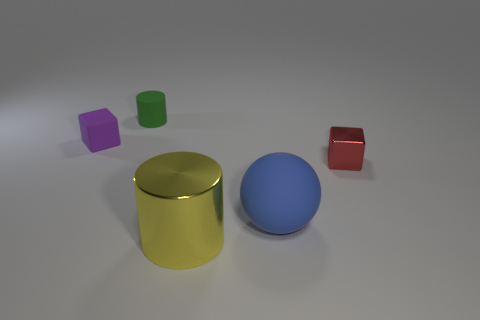There is a big thing to the right of the large metallic cylinder; what shape is it?
Make the answer very short. Sphere. Does the metal thing that is in front of the small red block have the same shape as the rubber object that is in front of the red shiny object?
Your answer should be compact. No. Are there the same number of rubber cubes that are in front of the ball and big yellow objects?
Your answer should be compact. No. Is there anything else that is the same size as the metal cylinder?
Offer a very short reply. Yes. What is the material of the other thing that is the same shape as the purple rubber thing?
Keep it short and to the point. Metal. What is the shape of the blue rubber thing that is right of the tiny thing on the left side of the small green matte thing?
Make the answer very short. Sphere. Is the cylinder in front of the red thing made of the same material as the big blue ball?
Make the answer very short. No. Is the number of small red cubes to the right of the metallic cylinder the same as the number of tiny red blocks behind the blue rubber ball?
Offer a terse response. Yes. What number of yellow shiny cylinders are in front of the big object left of the big rubber thing?
Your response must be concise. 0. There is a cylinder that is behind the big blue sphere; is it the same color as the large object that is left of the large blue object?
Your answer should be compact. No. 